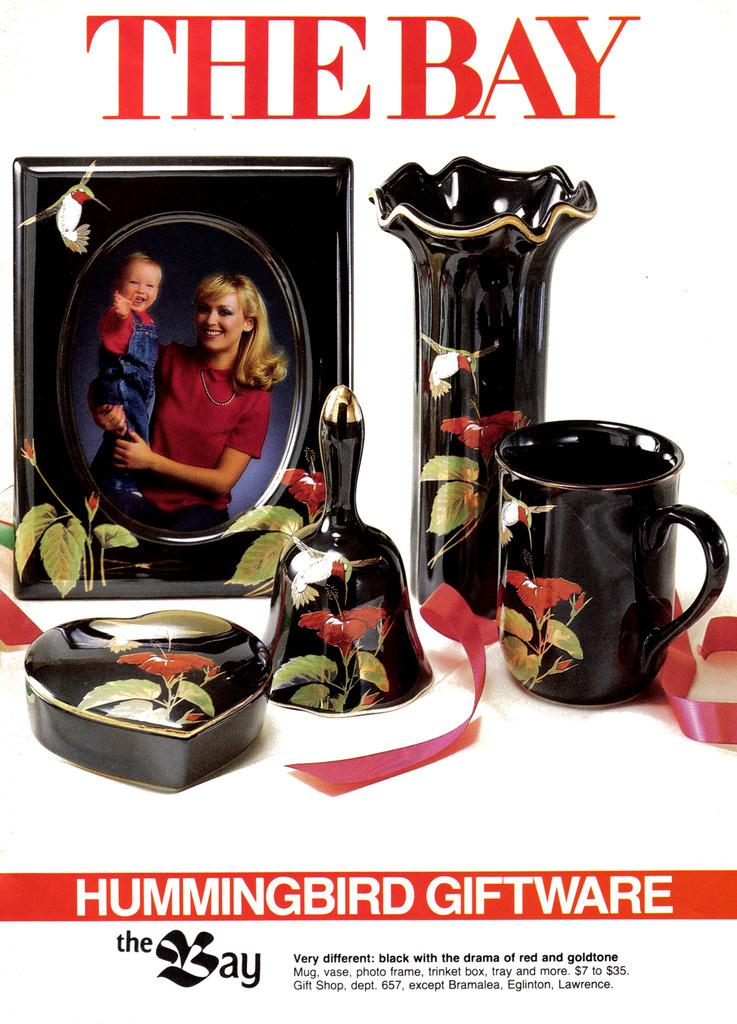<image>
Share a concise interpretation of the image provided. An ad for Hummingbird Gift ware from The Bay. 